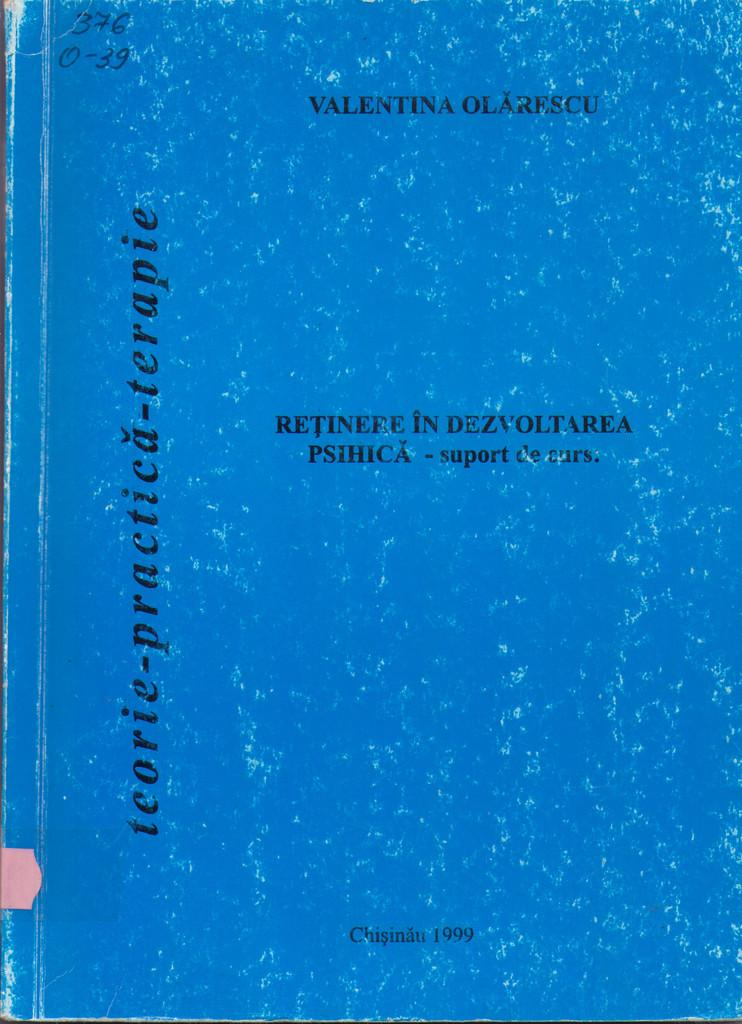<image>
Present a compact description of the photo's key features. The blue book shown here was written in 1999 